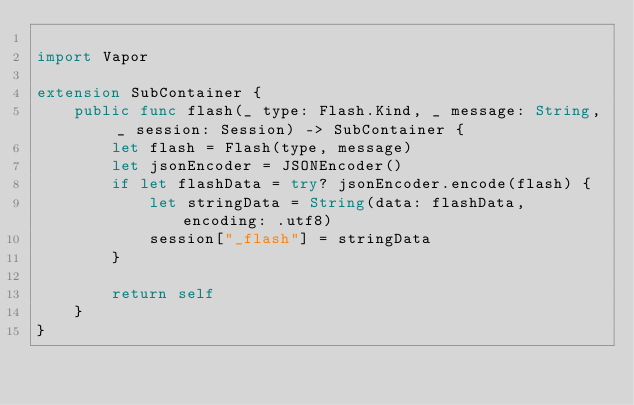<code> <loc_0><loc_0><loc_500><loc_500><_Swift_>
import Vapor

extension SubContainer {
    public func flash(_ type: Flash.Kind, _ message: String, _ session: Session) -> SubContainer {
        let flash = Flash(type, message)
        let jsonEncoder = JSONEncoder()
        if let flashData = try? jsonEncoder.encode(flash) {
            let stringData = String(data: flashData, encoding: .utf8)
            session["_flash"] = stringData
        }
        
        return self
    }
}
</code> 